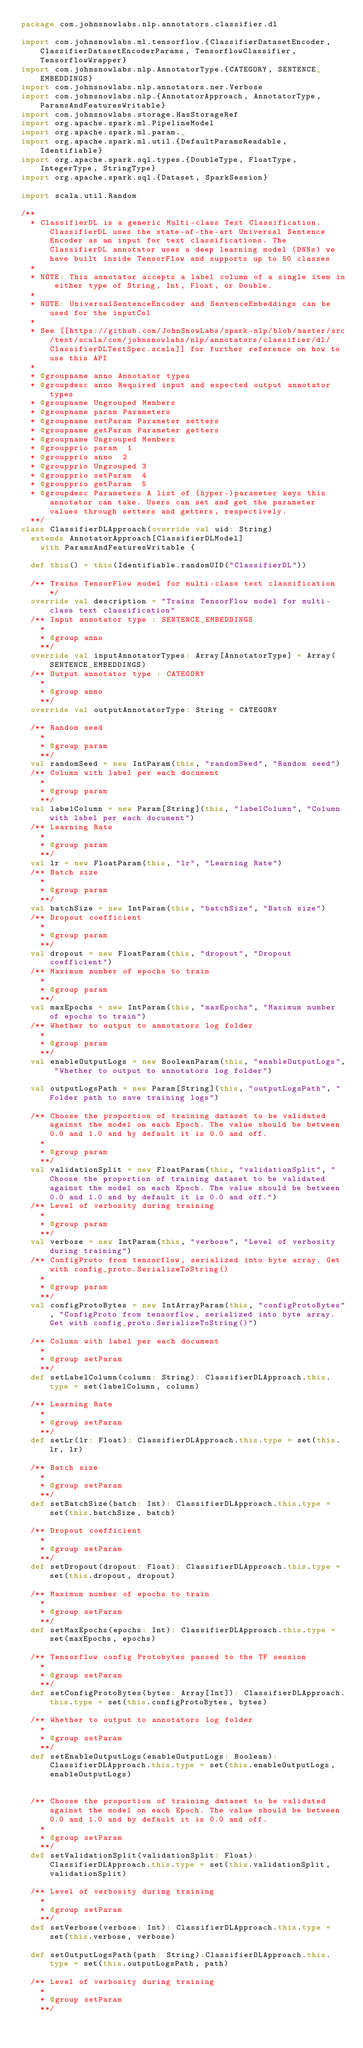<code> <loc_0><loc_0><loc_500><loc_500><_Scala_>package com.johnsnowlabs.nlp.annotators.classifier.dl

import com.johnsnowlabs.ml.tensorflow.{ClassifierDatasetEncoder, ClassifierDatasetEncoderParams, TensorflowClassifier, TensorflowWrapper}
import com.johnsnowlabs.nlp.AnnotatorType.{CATEGORY, SENTENCE_EMBEDDINGS}
import com.johnsnowlabs.nlp.annotators.ner.Verbose
import com.johnsnowlabs.nlp.{AnnotatorApproach, AnnotatorType, ParamsAndFeaturesWritable}
import com.johnsnowlabs.storage.HasStorageRef
import org.apache.spark.ml.PipelineModel
import org.apache.spark.ml.param._
import org.apache.spark.ml.util.{DefaultParamsReadable, Identifiable}
import org.apache.spark.sql.types.{DoubleType, FloatType, IntegerType, StringType}
import org.apache.spark.sql.{Dataset, SparkSession}

import scala.util.Random

/**
  * ClassifierDL is a generic Multi-class Text Classification. ClassifierDL uses the state-of-the-art Universal Sentence Encoder as an input for text classifications. The ClassifierDL annotator uses a deep learning model (DNNs) we have built inside TensorFlow and supports up to 50 classes
  *
  * NOTE: This annotator accepts a label column of a single item in either type of String, Int, Float, or Double.
  *
  * NOTE: UniversalSentenceEncoder and SentenceEmbeddings can be used for the inputCol
  *
  * See [[https://github.com/JohnSnowLabs/spark-nlp/blob/master/src/test/scala/com/johnsnowlabs/nlp/annotators/classifier/dl/ClassifierDLTestSpec.scala]] for further reference on how to use this API
  *
  * @groupname anno Annotator types
  * @groupdesc anno Required input and expected output annotator types
  * @groupname Ungrouped Members
  * @groupname param Parameters
  * @groupname setParam Parameter setters
  * @groupname getParam Parameter getters
  * @groupname Ungrouped Members
  * @groupprio param  1
  * @groupprio anno  2
  * @groupprio Ungrouped 3
  * @groupprio setParam  4
  * @groupprio getParam  5
  * @groupdesc Parameters A list of (hyper-)parameter keys this annotator can take. Users can set and get the parameter values through setters and getters, respectively.
  **/
class ClassifierDLApproach(override val uid: String)
  extends AnnotatorApproach[ClassifierDLModel]
    with ParamsAndFeaturesWritable {

  def this() = this(Identifiable.randomUID("ClassifierDL"))

  /** Trains TensorFlow model for multi-class text classification */
  override val description = "Trains TensorFlow model for multi-class text classification"
  /** Input annotator type : SENTENCE_EMBEDDINGS
    *
    * @group anno
    **/
  override val inputAnnotatorTypes: Array[AnnotatorType] = Array(SENTENCE_EMBEDDINGS)
  /** Output annotator type : CATEGORY
    *
    * @group anno
    **/
  override val outputAnnotatorType: String = CATEGORY

  /** Random seed
    *
    * @group param
    **/
  val randomSeed = new IntParam(this, "randomSeed", "Random seed")
  /** Column with label per each document
    *
    * @group param
    **/
  val labelColumn = new Param[String](this, "labelColumn", "Column with label per each document")
  /** Learning Rate
    *
    * @group param
    **/
  val lr = new FloatParam(this, "lr", "Learning Rate")
  /** Batch size
    *
    * @group param
    **/
  val batchSize = new IntParam(this, "batchSize", "Batch size")
  /** Dropout coefficient
    *
    * @group param
    **/
  val dropout = new FloatParam(this, "dropout", "Dropout coefficient")
  /** Maximum number of epochs to train
    *
    * @group param
    **/
  val maxEpochs = new IntParam(this, "maxEpochs", "Maximum number of epochs to train")
  /** Whether to output to annotators log folder
    *
    * @group param
    **/
  val enableOutputLogs = new BooleanParam(this, "enableOutputLogs", "Whether to output to annotators log folder")

  val outputLogsPath = new Param[String](this, "outputLogsPath", "Folder path to save training logs")

  /** Choose the proportion of training dataset to be validated against the model on each Epoch. The value should be between 0.0 and 1.0 and by default it is 0.0 and off.
    *
    * @group param
    **/
  val validationSplit = new FloatParam(this, "validationSplit", "Choose the proportion of training dataset to be validated against the model on each Epoch. The value should be between 0.0 and 1.0 and by default it is 0.0 and off.")
  /** Level of verbosity during training
    *
    * @group param
    **/
  val verbose = new IntParam(this, "verbose", "Level of verbosity during training")
  /** ConfigProto from tensorflow, serialized into byte array. Get with config_proto.SerializeToString()
    *
    * @group param
    **/
  val configProtoBytes = new IntArrayParam(this, "configProtoBytes", "ConfigProto from tensorflow, serialized into byte array. Get with config_proto.SerializeToString()")

  /** Column with label per each document
    *
    * @group setParam
    **/
  def setLabelColumn(column: String): ClassifierDLApproach.this.type = set(labelColumn, column)

  /** Learning Rate
    *
    * @group setParam
    **/
  def setLr(lr: Float): ClassifierDLApproach.this.type = set(this.lr, lr)

  /** Batch size
    *
    * @group setParam
    **/
  def setBatchSize(batch: Int): ClassifierDLApproach.this.type = set(this.batchSize, batch)

  /** Dropout coefficient
    *
    * @group setParam
    **/
  def setDropout(dropout: Float): ClassifierDLApproach.this.type = set(this.dropout, dropout)

  /** Maximum number of epochs to train
    *
    * @group setParam
    **/
  def setMaxEpochs(epochs: Int): ClassifierDLApproach.this.type = set(maxEpochs, epochs)

  /** Tensorflow config Protobytes passed to the TF session
    *
    * @group setParam
    **/
  def setConfigProtoBytes(bytes: Array[Int]): ClassifierDLApproach.this.type = set(this.configProtoBytes, bytes)

  /** Whether to output to annotators log folder
    *
    * @group setParam
    **/
  def setEnableOutputLogs(enableOutputLogs: Boolean): ClassifierDLApproach.this.type = set(this.enableOutputLogs, enableOutputLogs)


  /** Choose the proportion of training dataset to be validated against the model on each Epoch. The value should be between 0.0 and 1.0 and by default it is 0.0 and off.
    *
    * @group setParam
    **/
  def setValidationSplit(validationSplit: Float): ClassifierDLApproach.this.type = set(this.validationSplit, validationSplit)

  /** Level of verbosity during training
    *
    * @group setParam
    **/
  def setVerbose(verbose: Int): ClassifierDLApproach.this.type = set(this.verbose, verbose)
  
  def setOutputLogsPath(path: String):ClassifierDLApproach.this.type = set(this.outputLogsPath, path)

  /** Level of verbosity during training
    *
    * @group setParam
    **/</code> 